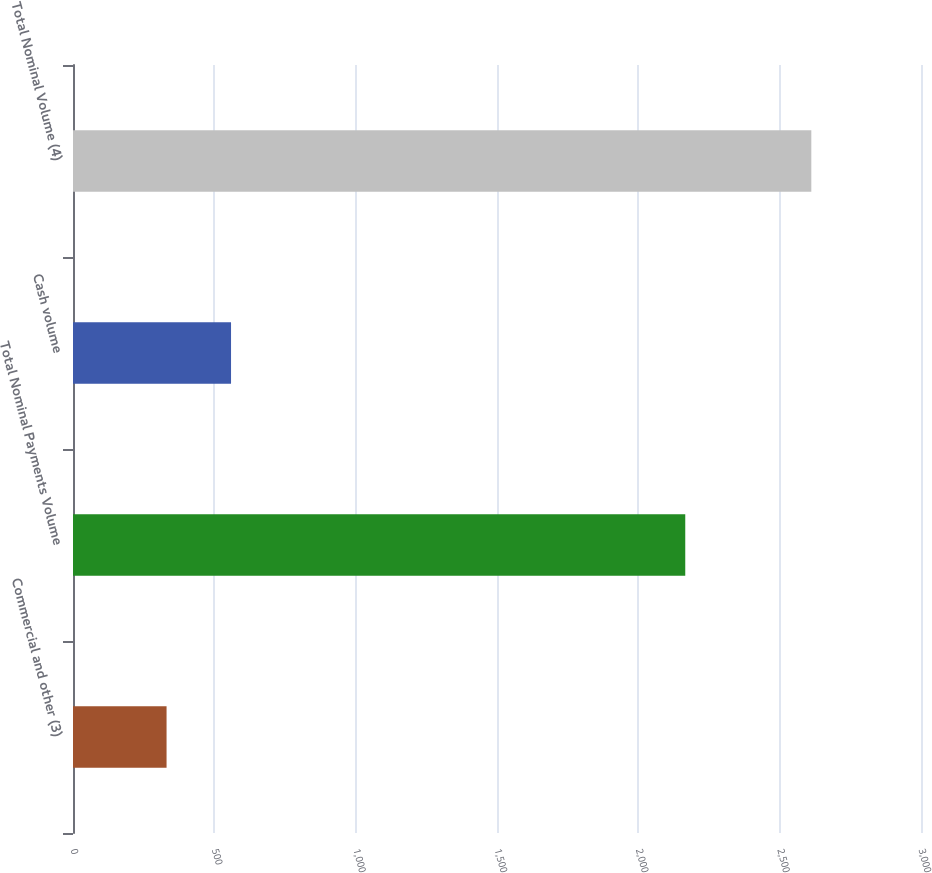Convert chart to OTSL. <chart><loc_0><loc_0><loc_500><loc_500><bar_chart><fcel>Commercial and other (3)<fcel>Total Nominal Payments Volume<fcel>Cash volume<fcel>Total Nominal Volume (4)<nl><fcel>331<fcel>2166<fcel>559.1<fcel>2612<nl></chart> 